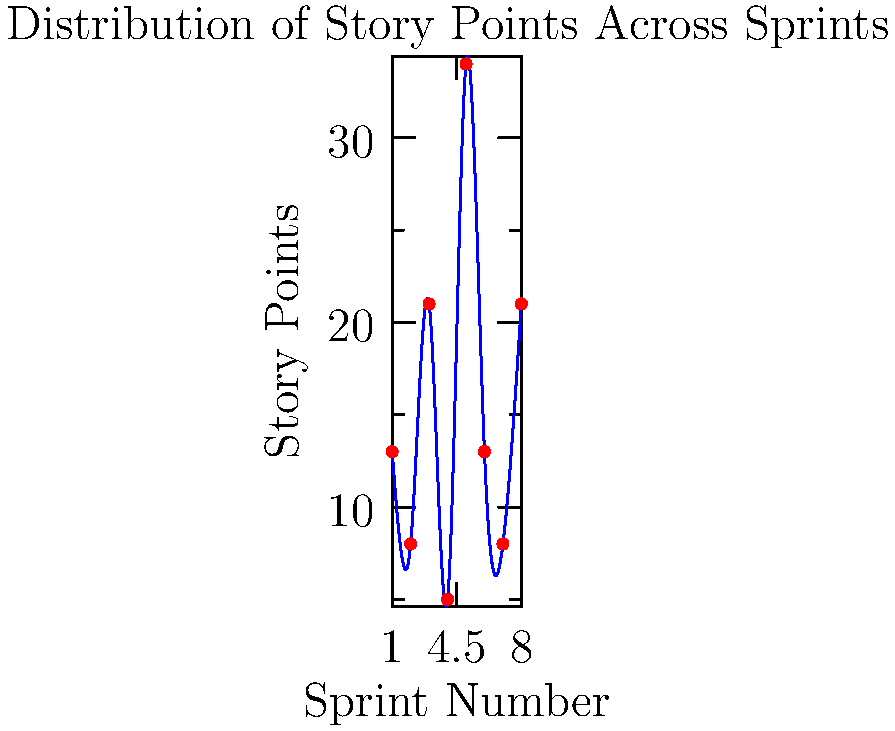Based on the scatter plot showing the distribution of story points across different sprints, what pattern can be observed in the team's velocity, and how might this impact sprint planning? To analyze the pattern in the team's velocity and its impact on sprint planning, let's follow these steps:

1. Observe the data points:
   Sprint 1: 13 points
   Sprint 2: 8 points
   Sprint 3: 21 points
   Sprint 4: 5 points
   Sprint 5: 34 points
   Sprint 6: 13 points
   Sprint 7: 8 points
   Sprint 8: 21 points

2. Identify the pattern:
   The story points fluctuate significantly between sprints, showing no consistent trend or stability.

3. Calculate the range:
   Minimum: 5 points (Sprint 4)
   Maximum: 34 points (Sprint 5)
   Range: 34 - 5 = 29 points

4. Analyze the implications:
   a) Inconsistent velocity: The team's output varies greatly from sprint to sprint.
   b) Unpredictability: It's challenging to accurately forecast the team's capacity for future sprints.
   c) Potential causes: This pattern might indicate issues with story point estimation, varying team capacity, or external factors affecting productivity.

5. Impact on sprint planning:
   a) Difficulty in commitment: The team may struggle to commit to a consistent number of story points per sprint.
   b) Risk of over/under-planning: Stakeholders might find it hard to predict when features will be delivered.
   c) Need for buffer: Sprint plans may require more flexibility to accommodate the high variability.

6. Recommendations:
   a) Investigate causes of variability and address them if possible.
   b) Use average velocity with caution, considering the high variability.
   c) Implement more frequent re-estimation and planning sessions to adapt to the changing velocity.
   d) Focus on improving estimation accuracy and consistency in story point assignment.
Answer: Highly variable velocity, complicating sprint planning and necessitating adaptive approaches. 